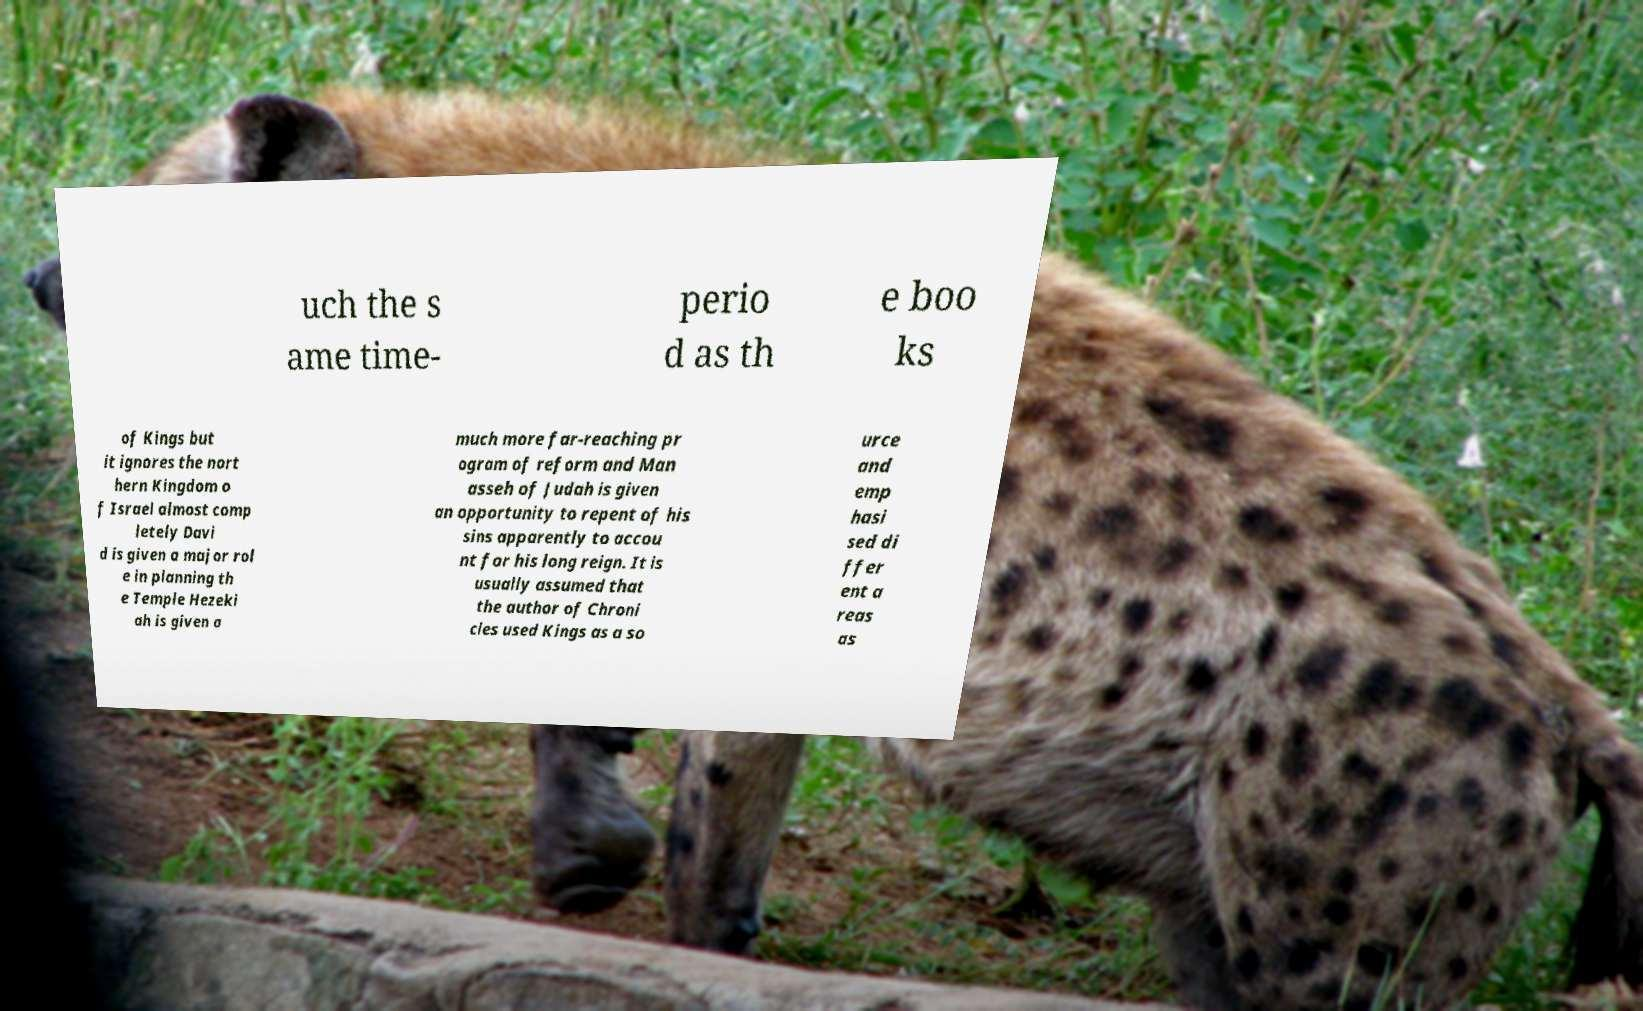There's text embedded in this image that I need extracted. Can you transcribe it verbatim? uch the s ame time- perio d as th e boo ks of Kings but it ignores the nort hern Kingdom o f Israel almost comp letely Davi d is given a major rol e in planning th e Temple Hezeki ah is given a much more far-reaching pr ogram of reform and Man asseh of Judah is given an opportunity to repent of his sins apparently to accou nt for his long reign. It is usually assumed that the author of Chroni cles used Kings as a so urce and emp hasi sed di ffer ent a reas as 